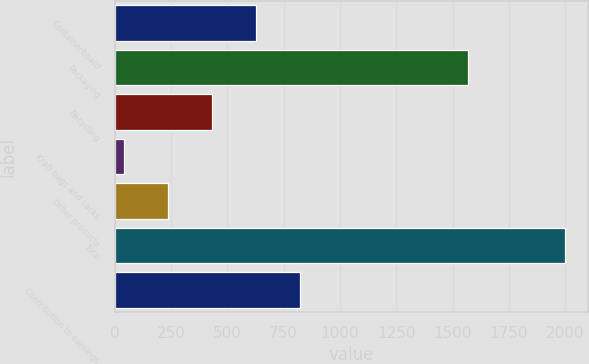Convert chart to OTSL. <chart><loc_0><loc_0><loc_500><loc_500><bar_chart><fcel>Containerboard<fcel>Packaging<fcel>Recycling<fcel>Kraft bags and sacks<fcel>Other products<fcel>Total<fcel>Contribution to earnings<nl><fcel>627.7<fcel>1570<fcel>431.8<fcel>40<fcel>235.9<fcel>1999<fcel>823.6<nl></chart> 